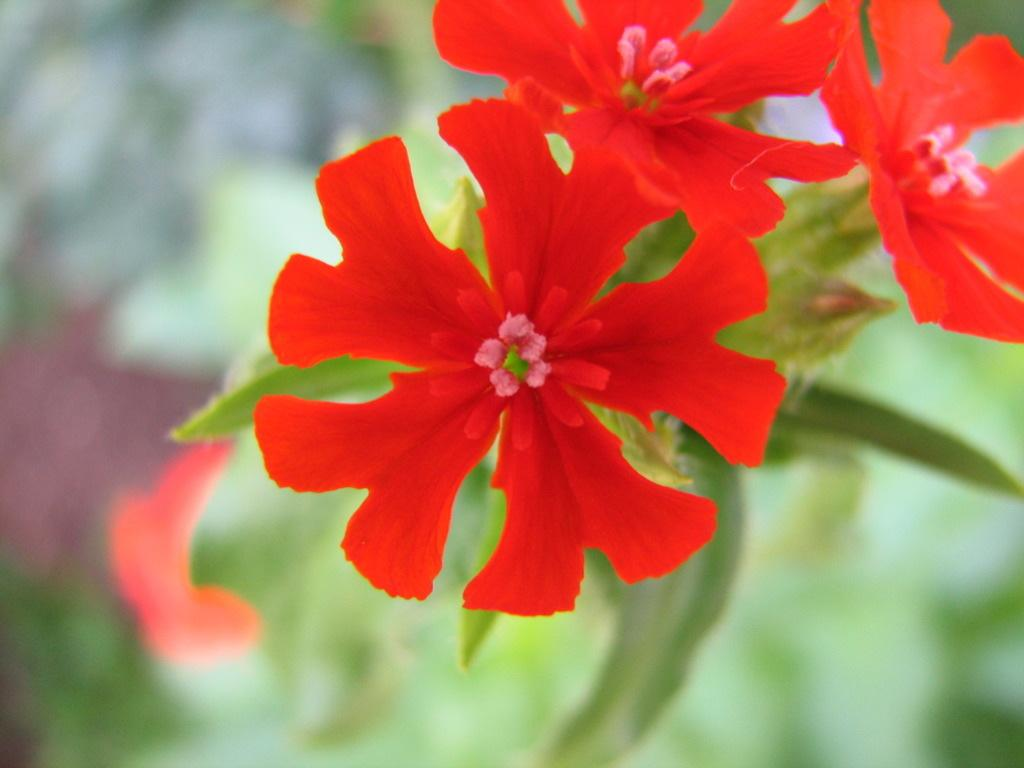What is the main subject of the image? There is a plant in the image. What specific feature of the plant is mentioned? The plant has flowers. What color are the flowers? The flowers are red in color. What can be observed about the background of the image? The background of the image is green, and it is blurred. How many basketballs can be seen in the image? There are no basketballs present in the image. What type of gold ornament is hanging from the plant in the image? There is no gold ornament present in the image; it features a plant with red flowers and a green, blurred background. 